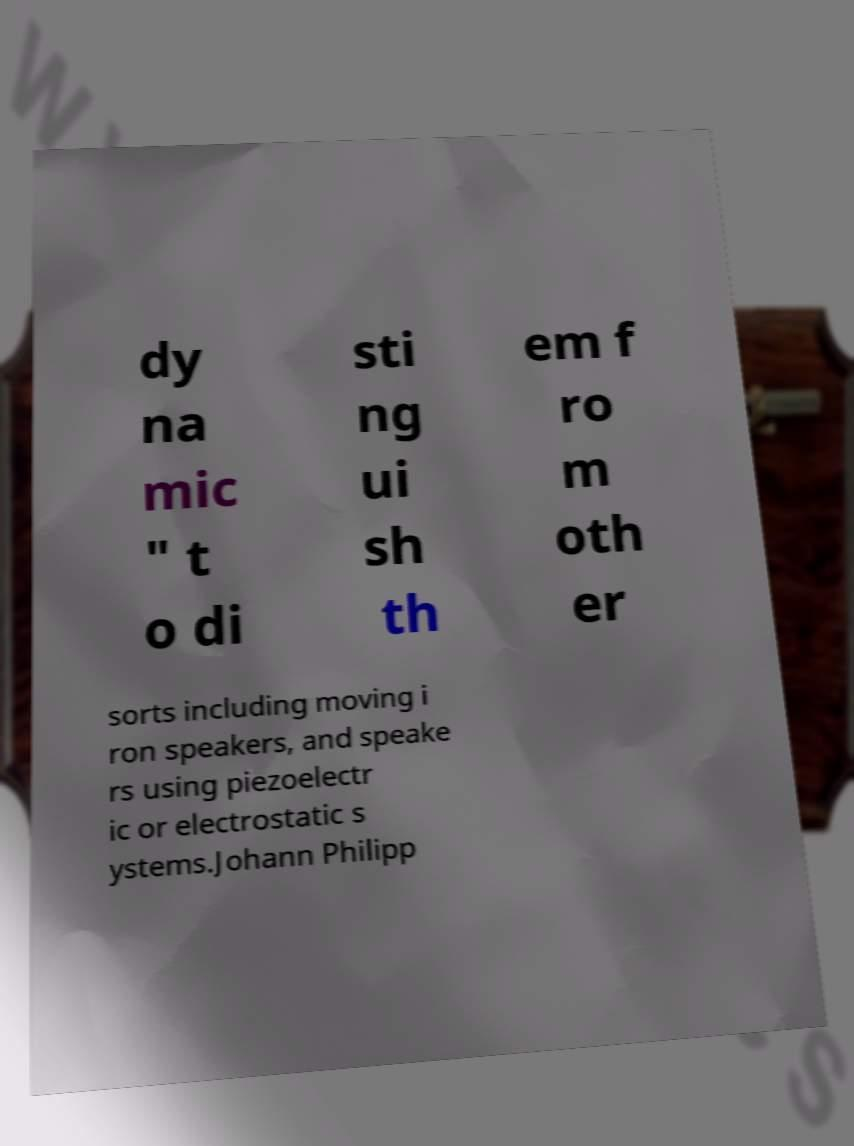There's text embedded in this image that I need extracted. Can you transcribe it verbatim? dy na mic " t o di sti ng ui sh th em f ro m oth er sorts including moving i ron speakers, and speake rs using piezoelectr ic or electrostatic s ystems.Johann Philipp 